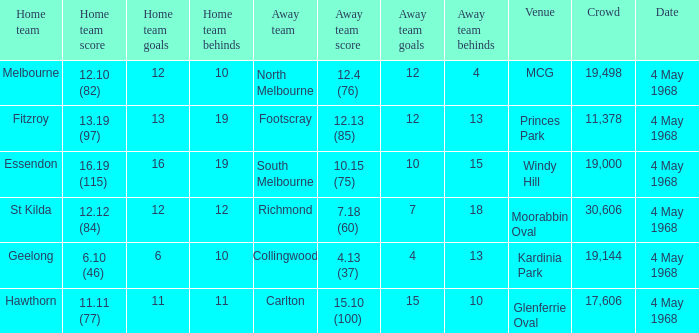What away team played at Kardinia Park? 4.13 (37). 